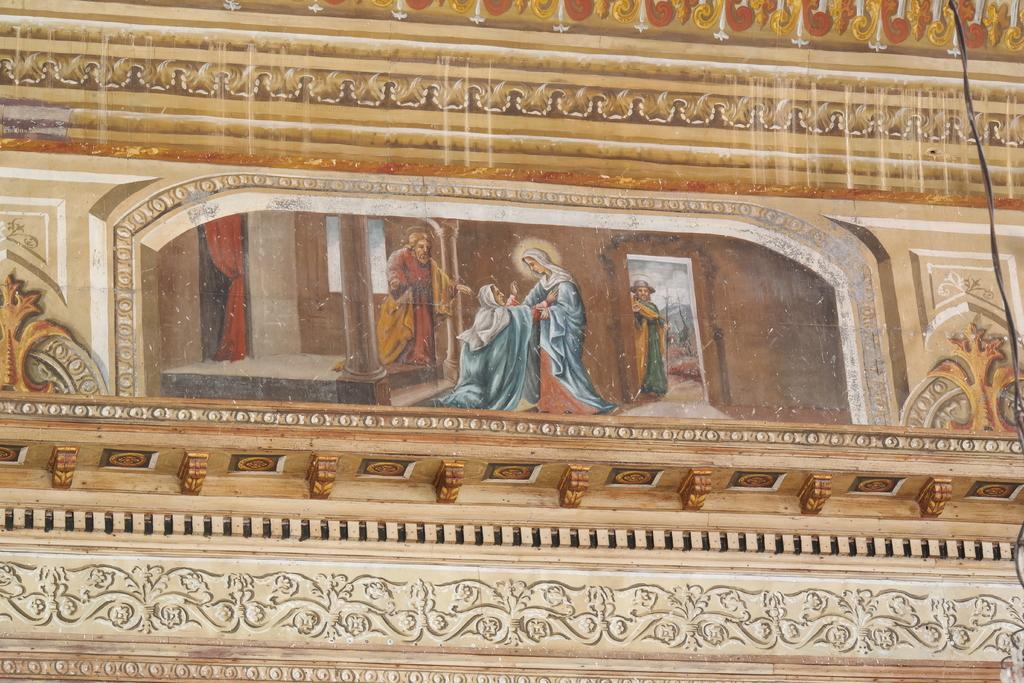What is featured on the poster in the image? The facts provided do not specify the content of the poster. What type of surface is the poster attached to in the image? There is a wall in the image, and the poster is likely attached to it. Can you describe the design on the wall in the image? The facts provided mention that there is a design on the wall, but the specific design is not described. What else can be seen in the image besides the poster and wall? There is a cable wire visible in the image. How much money is shown on the suit in the image? There is no suit or money present in the image. What type of tail is attached to the poster in the image? There is no tail attached to the poster in the image. 